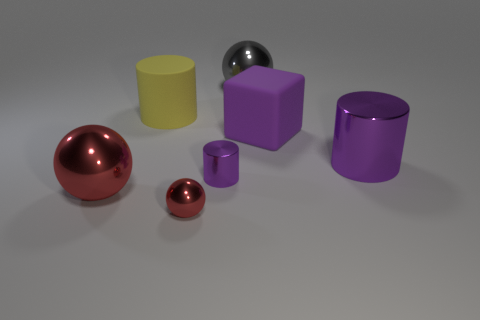Is the small cylinder the same color as the big rubber cube?
Your answer should be compact. Yes. What color is the small thing that is the same shape as the large gray metal object?
Keep it short and to the point. Red. Is the number of large purple matte things that are to the left of the large gray shiny sphere the same as the number of large gray metallic objects that are to the left of the large yellow thing?
Your answer should be compact. Yes. Is there a big yellow cylinder?
Offer a very short reply. Yes. What size is the other purple metallic object that is the same shape as the big purple metal object?
Your answer should be compact. Small. There is a metal object that is in front of the big red metal ball; what size is it?
Your answer should be compact. Small. Are there more red balls to the left of the small red thing than small brown shiny cylinders?
Your answer should be very brief. Yes. What is the shape of the purple rubber thing?
Your response must be concise. Cube. There is a block that is to the right of the gray thing; is its color the same as the small shiny object behind the small red object?
Ensure brevity in your answer.  Yes. Do the big gray metal thing and the small red shiny thing have the same shape?
Offer a very short reply. Yes. 